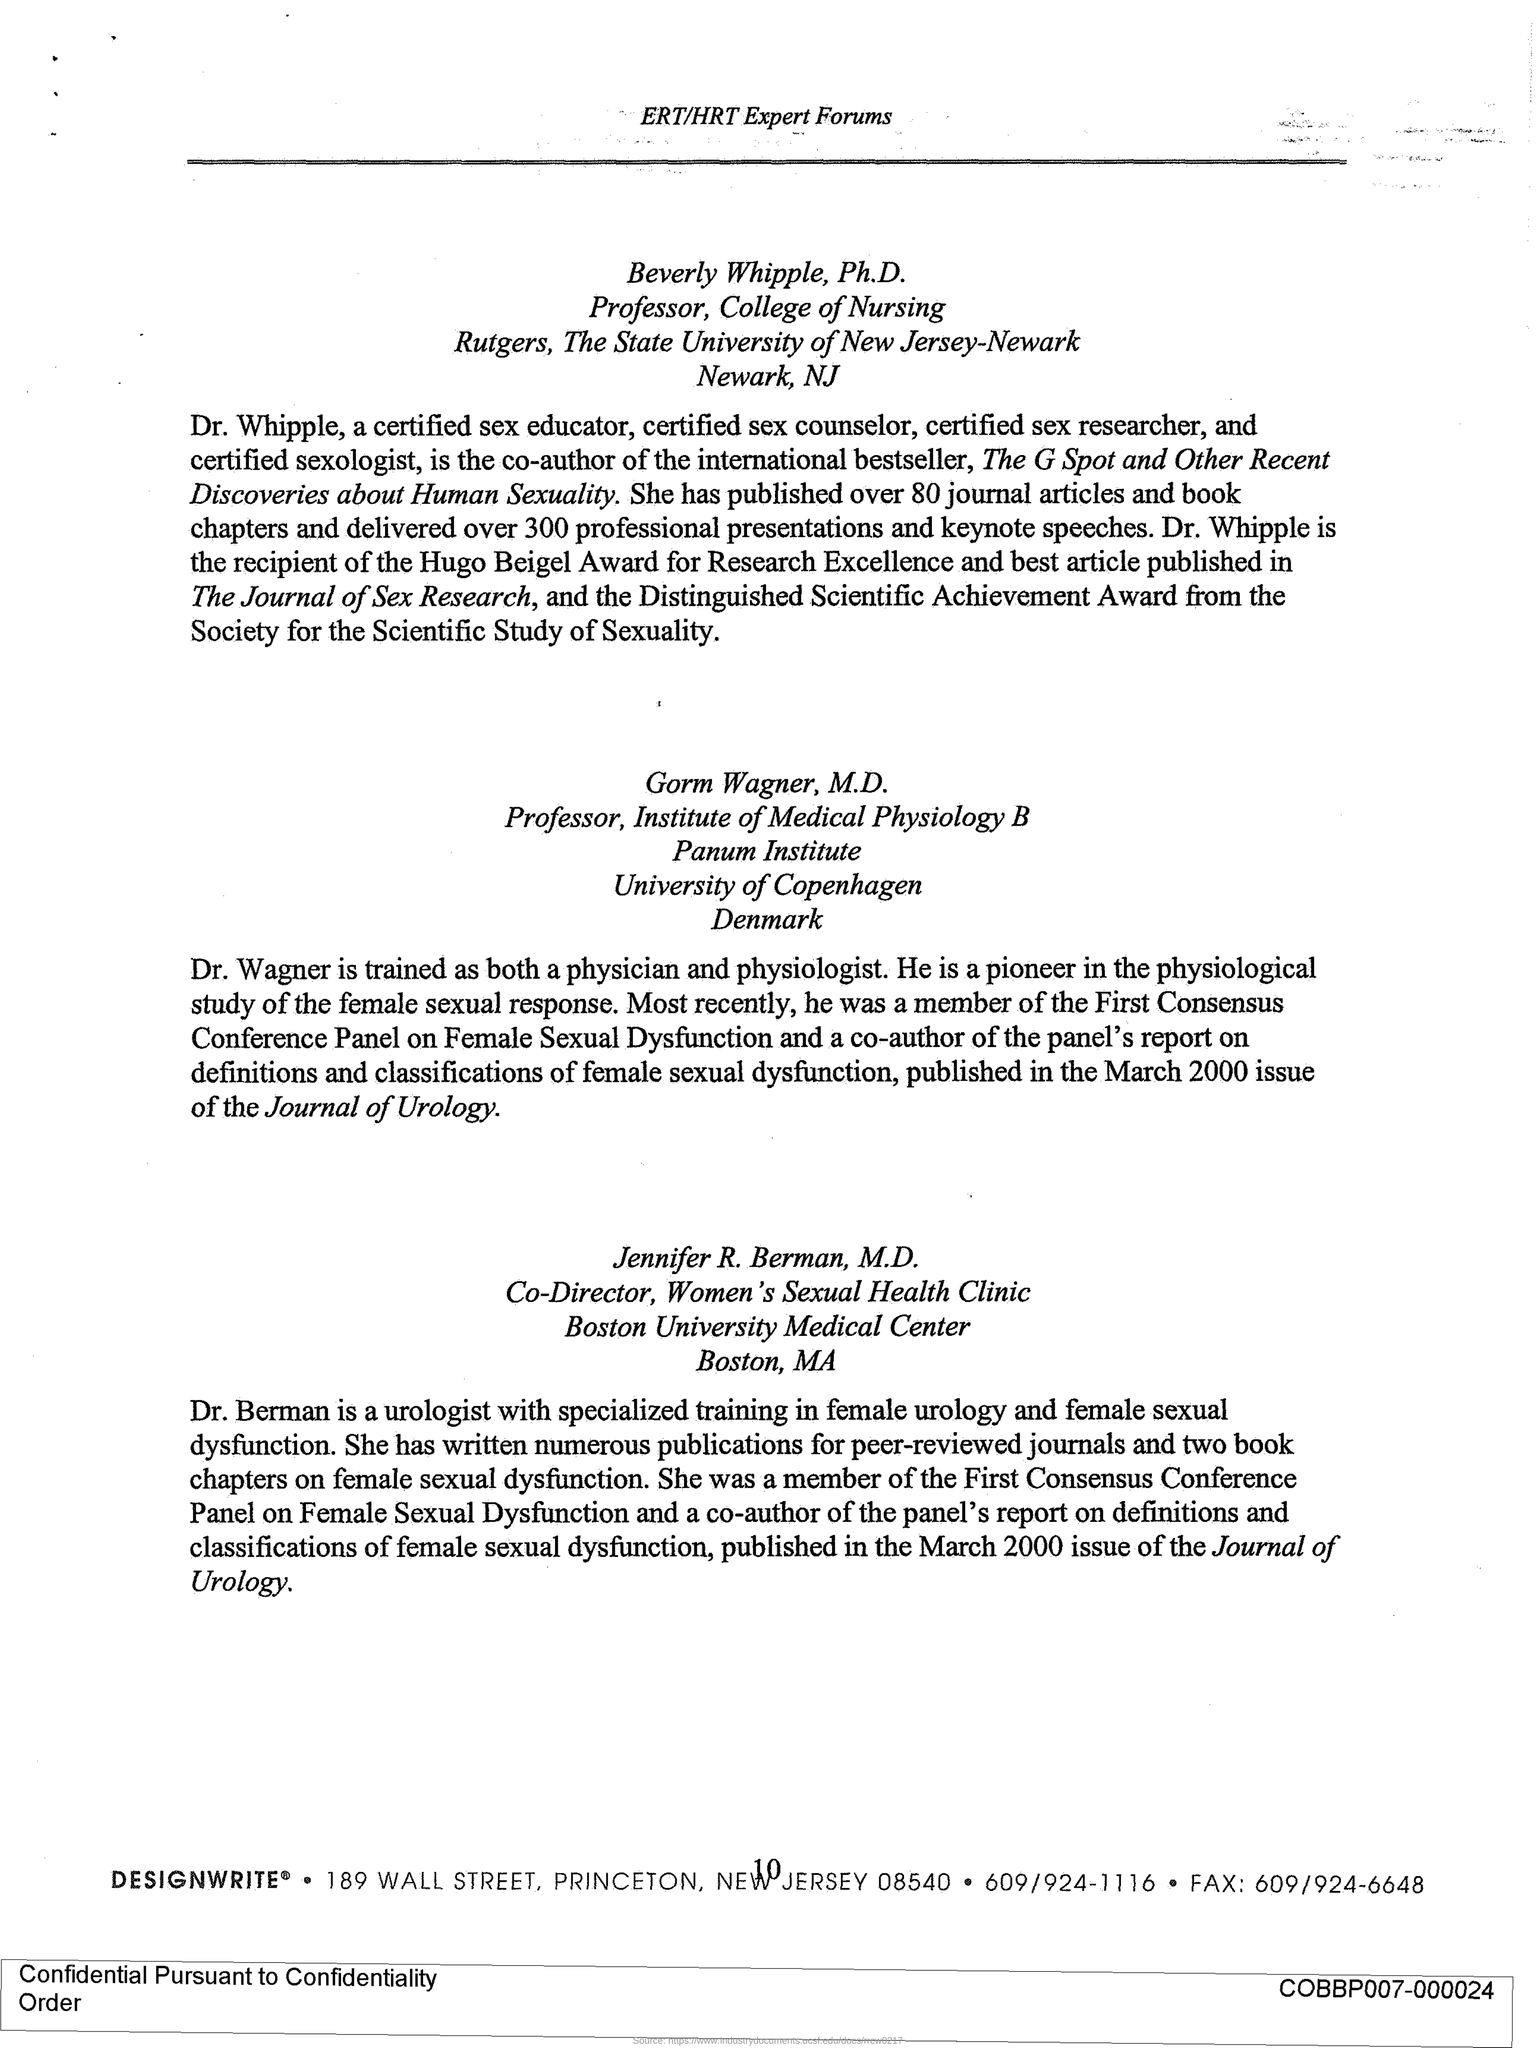Who is the co-author of The G spot?
Keep it short and to the point. Dr. Whipple. Who is trained as both Physician and physiologist?
Provide a succinct answer. Dr. Wagner. 